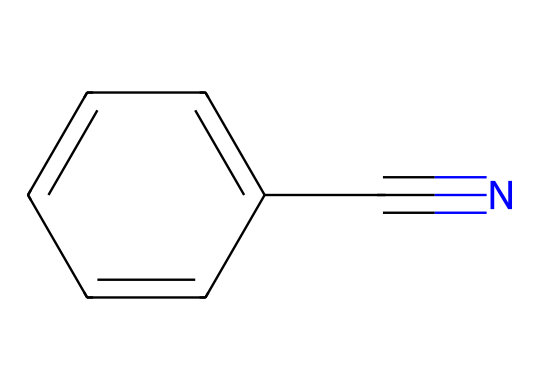What is the molecular formula of benzonitrile? To determine the molecular formula, identify the number of carbon (C), hydrogen (H), and nitrogen (N) atoms in the structure. There are seven carbon atoms, five hydrogen atoms, and one nitrogen atom in benzonitrile. Therefore, the molecular formula is C7H5N.
Answer: C7H5N How many aromatic rings are present in benzonitrile? Benzonitrile contains a phenyl ring, which is an aromatic ring consisting of six carbons arranged in a cyclic structure with alternating double bonds. There is only one aromatic ring in benzonitrile.
Answer: one What type of functional group is present in benzonitrile? The presence of a nitrile group, indicated by the carbon triple bonded to nitrogen (C#N) at the end of the molecule, is characteristic of nitriles. Therefore, the functional group is a nitrile.
Answer: nitrile What is the total number of atoms in benzonitrile? To find the total number of atoms, sum the carbon, hydrogen, and nitrogen atoms. There are 7 carbon atoms, 5 hydrogen atoms, and 1 nitrogen atom, which totals 13 atoms.
Answer: 13 What is the hybridization of the carbon atom in the nitrile functional group of benzonitrile? The carbon atom in the nitrile functional group is triple bonded to nitrogen, which indicates sp hybridization, allowing for linear geometry. Therefore, the hybridization is sp.
Answer: sp How can the structure of benzonitrile contribute to its use in dyes for historical document restoration? Benzonitrile's structure, particularly the aromatic ring, can be conducive to forming stable dye compounds, which are often required for restoration processes because of their ability to adhere to cellulose fibers in paper. This stability and affinity enhance its utility.
Answer: stability and affinity 